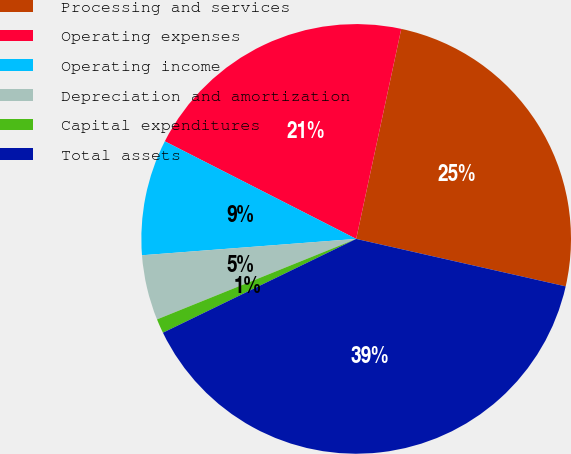<chart> <loc_0><loc_0><loc_500><loc_500><pie_chart><fcel>Processing and services<fcel>Operating expenses<fcel>Operating income<fcel>Depreciation and amortization<fcel>Capital expenditures<fcel>Total assets<nl><fcel>25.18%<fcel>20.86%<fcel>8.72%<fcel>4.9%<fcel>1.08%<fcel>39.26%<nl></chart> 